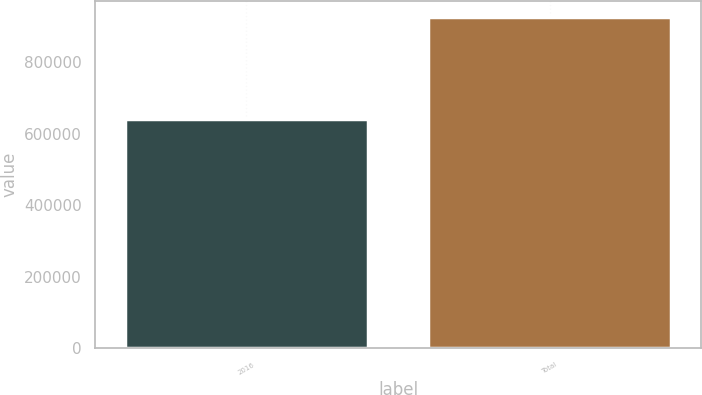<chart> <loc_0><loc_0><loc_500><loc_500><bar_chart><fcel>2016<fcel>Total<nl><fcel>640288<fcel>926443<nl></chart> 